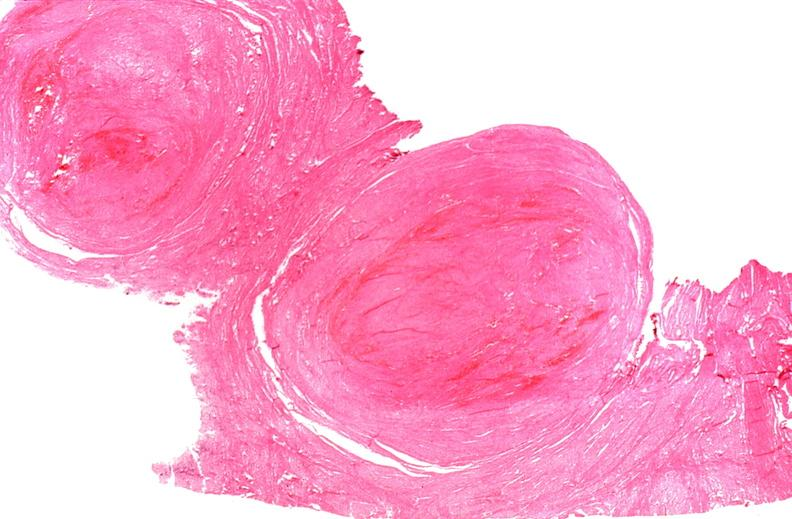what does this image show?
Answer the question using a single word or phrase. Uterus 